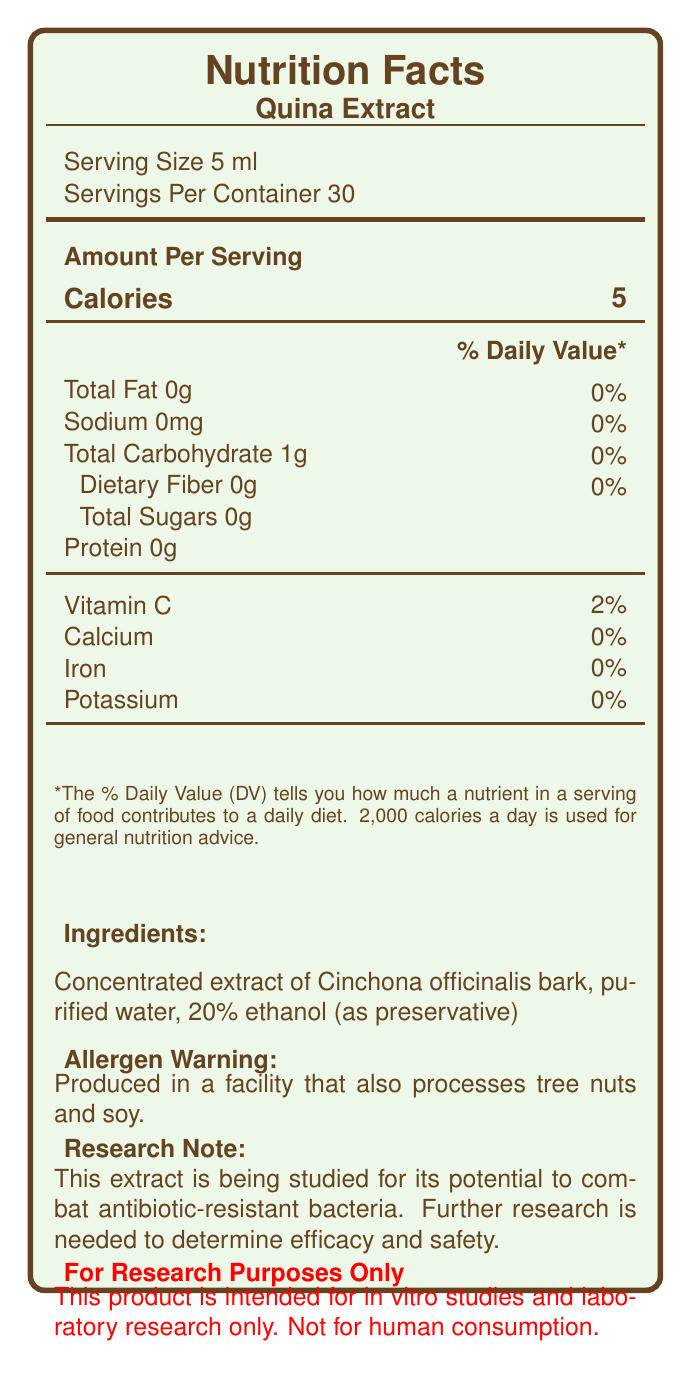what is the serving size of Quina Extract? The serving size is specified as "Serving Size 5 ml" in the document.
Answer: 5 ml how many calories are there per serving? The document lists "Calories 5" under the Amount Per Serving section.
Answer: 5 what are the ingredients of Quina Extract? The ingredients are mentioned under the ingredients section in the document.
Answer: Concentrated extract of Cinchona officinalis bark, purified water, 20% ethanol (as preservative) does this product contain any dietary fiber? The document shows "Dietary Fiber 0g," indicating no dietary fiber is present.
Answer: No how many servings per container? The document specifies "Servings Per Container 30."
Answer: 30 what is the percentage of daily value for Vitamin C per serving? The document lists Vitamin C as "2% DV."
Answer: 2% what is the total carbohydrate content per serving? A. 0g B. 1g C. 2g The document lists “Total Carbohydrate 1g” per serving, so the correct answer is B.
Answer: B is this product suitable for people with nut allergies? The allergen warning indicates it is produced in a facility that processes tree nuts, making it unsuitable for people with nut allergies.
Answer: No what is the main purpose of this Quina Extract according to the document? The document states "For research purposes only. Not for human consumption."
Answer: For research purposes only. which of the following minerals is present in significant quantities in Quina Extract? i. Calcium ii. Iron iii. Potassium iv. None The document indicates 0% DV for Calcium, Iron, and Potassium, meaning none of these minerals are present in significant quantities.
Answer: iv. None how should the Quina Extract be stored? Storage instructions in the document state: "Store in a cool, dry place. Keep away from direct sunlight."
Answer: Store in a cool, dry place. Keep away from direct sunlight. what kind of potential medicinal properties does this extract have? The document mentions the medicinal properties as having potential antimicrobial and anti-malarial properties.
Answer: Potential antimicrobial and anti-malarial properties. does this product contain any protein? The document lists "Protein 0g," indicating no protein is present.
Answer: No what is the batch number of the Quina Extract? The batch number is specified as "Batch Number: QE2023-0142" in the document.
Answer: QE2023-0142 what is the expiration date of the Quina Extract? The document mentions "Best if used within 2 years of production date."
Answer: Best if used within 2 years of production date. can you determine the efficacy of Quina Extract for combating antibiotic-resistant bacteria? The document states "Further research is needed to determine efficacy and safety," indicating that the efficacy is currently undetermined.
Answer: Not enough information 